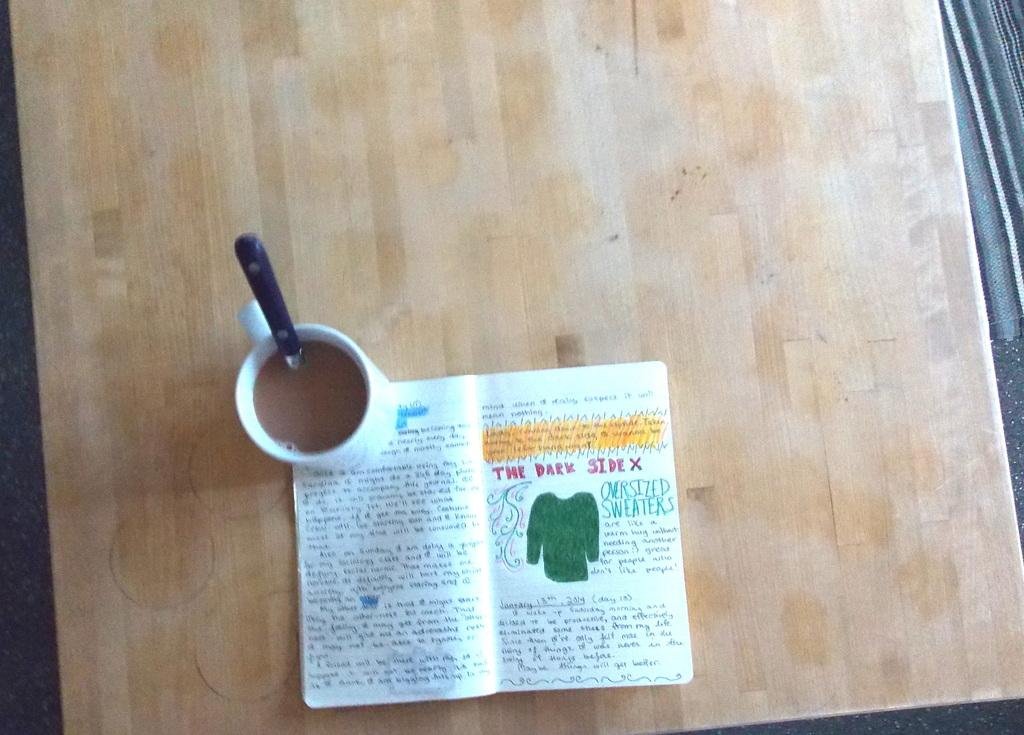<image>
Share a concise interpretation of the image provided. A small paperback, held open to a page with the header 'The Dark side". 